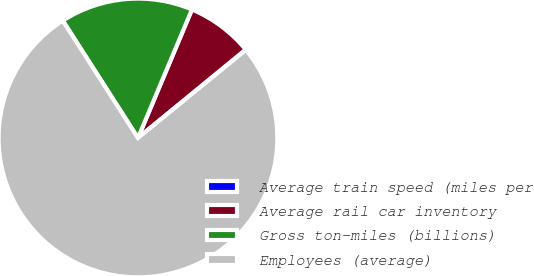<chart> <loc_0><loc_0><loc_500><loc_500><pie_chart><fcel>Average train speed (miles per<fcel>Average rail car inventory<fcel>Gross ton-miles (billions)<fcel>Employees (average)<nl><fcel>0.05%<fcel>7.73%<fcel>15.4%<fcel>76.82%<nl></chart> 